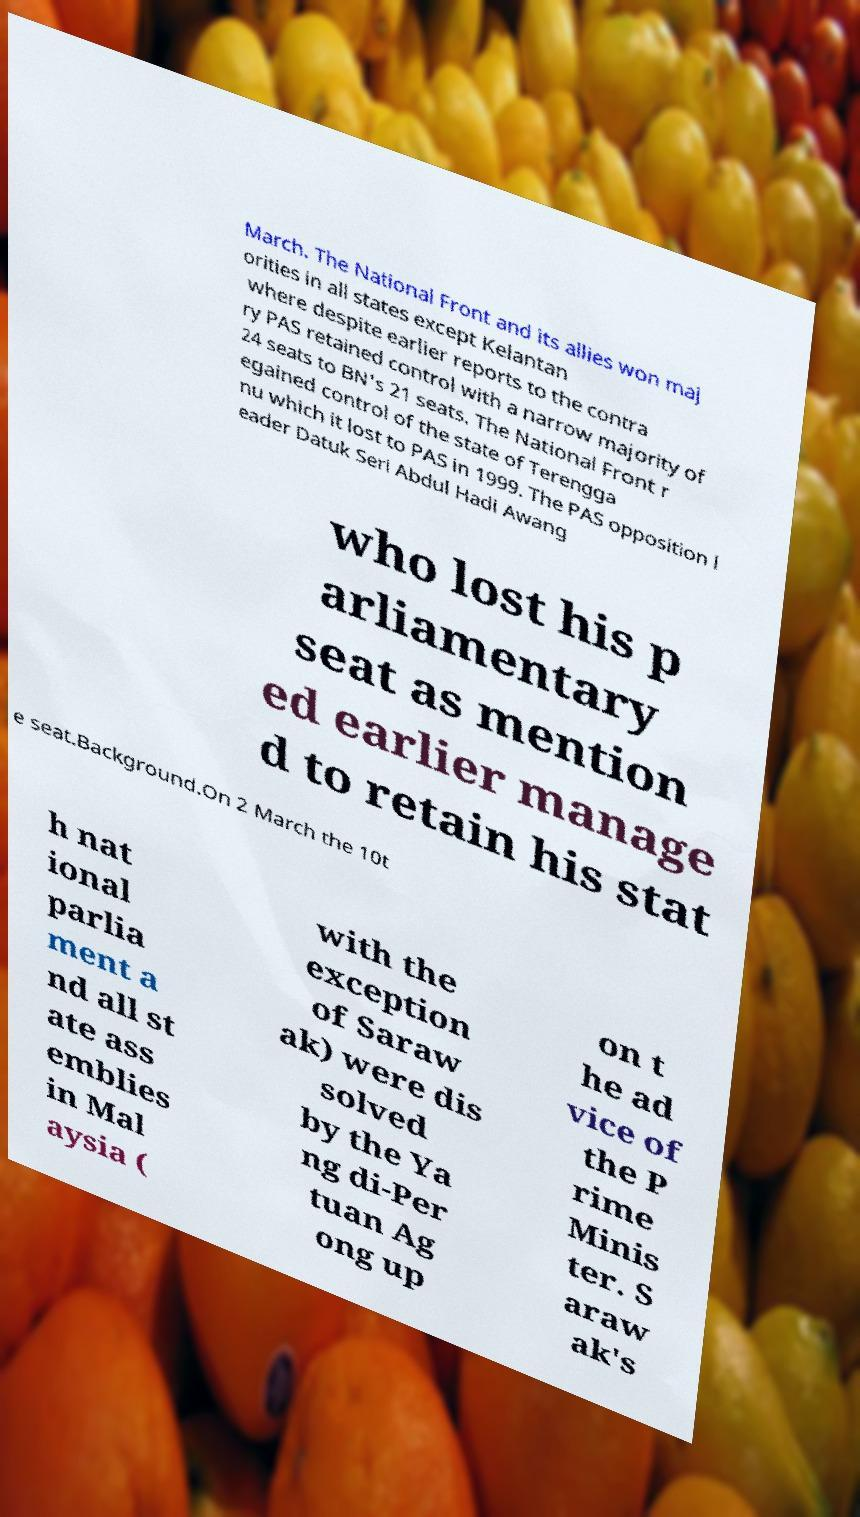Please read and relay the text visible in this image. What does it say? March. The National Front and its allies won maj orities in all states except Kelantan where despite earlier reports to the contra ry PAS retained control with a narrow majority of 24 seats to BN's 21 seats. The National Front r egained control of the state of Terengga nu which it lost to PAS in 1999. The PAS opposition l eader Datuk Seri Abdul Hadi Awang who lost his p arliamentary seat as mention ed earlier manage d to retain his stat e seat.Background.On 2 March the 10t h nat ional parlia ment a nd all st ate ass emblies in Mal aysia ( with the exception of Saraw ak) were dis solved by the Ya ng di-Per tuan Ag ong up on t he ad vice of the P rime Minis ter. S araw ak's 